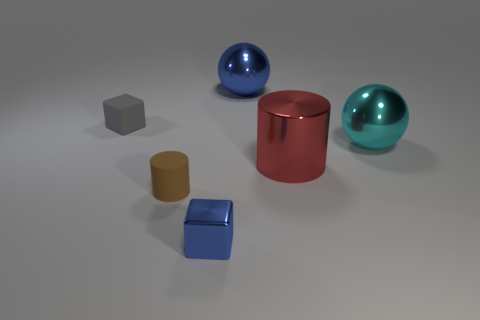What materials do the objects in the image seem to be made from? The objects exhibit various textures suggesting they are made of different materials. The small brown rectangular cuboid might be made of wood, the blue cylinder looks metallic, perhaps steel or aluminum, and the cyan spherical object might be crafted from ceramic or colored glass given its reflective surface. 